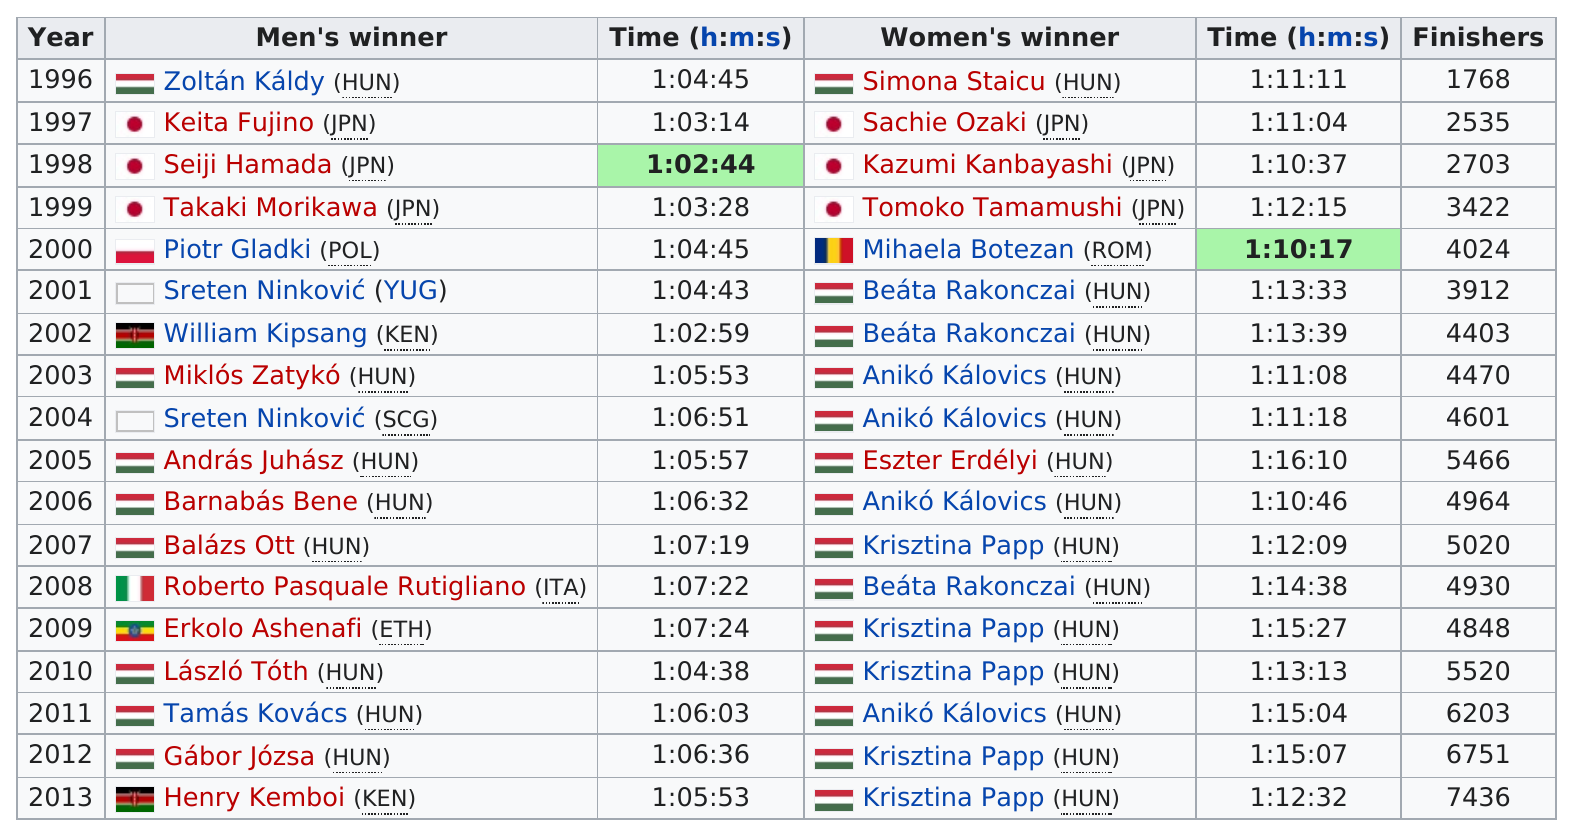Identify some key points in this picture. The consecutive winners of the Budapest Half Marathon are Beáta Rakonczai, Anikó Kálovics, and Krisztina Papp. The Budapest Half Marathon was held a total of 5 times before 2001. Hungary has had the most men's winners in the history of a specific competition or event. The fastest finisher in the 2012 Budapest Half Marathon was Gábor Józsa from Hungary. Zoltán Káldy and Simona Staicu were the male and female winners of the 1996 Budapest Half Marathon, respectively. 